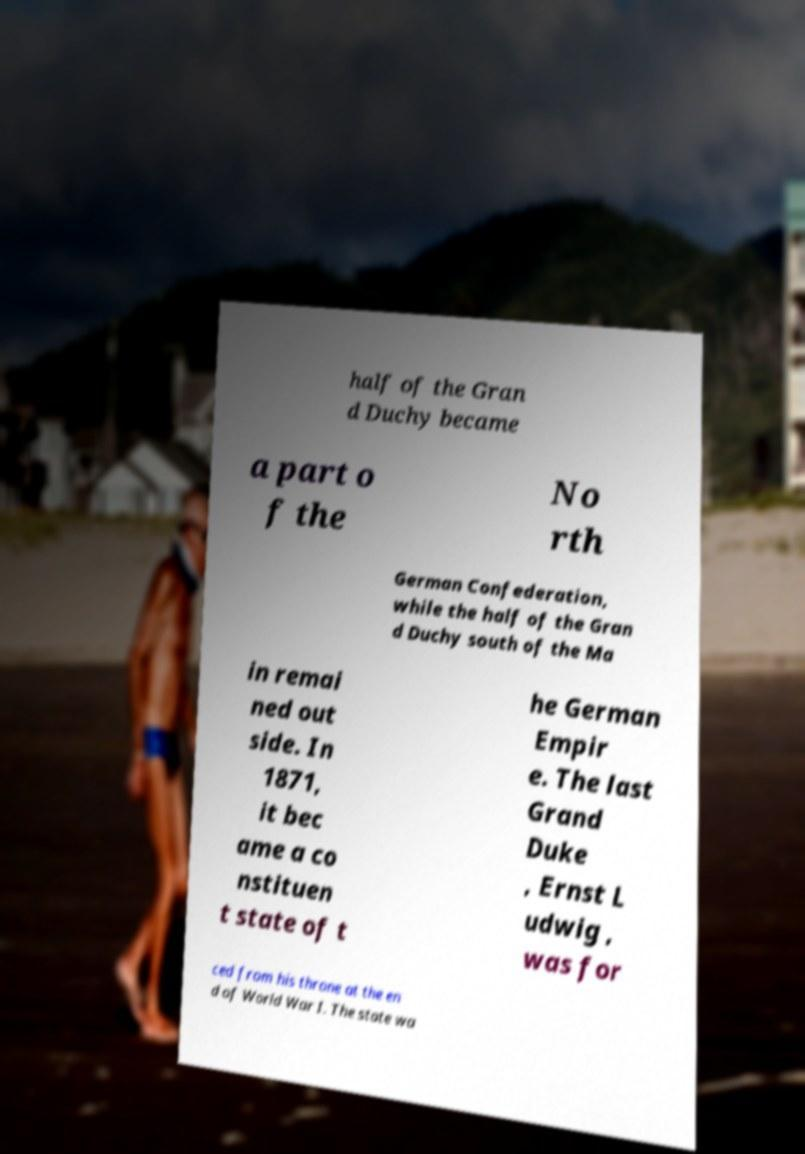Can you accurately transcribe the text from the provided image for me? half of the Gran d Duchy became a part o f the No rth German Confederation, while the half of the Gran d Duchy south of the Ma in remai ned out side. In 1871, it bec ame a co nstituen t state of t he German Empir e. The last Grand Duke , Ernst L udwig , was for ced from his throne at the en d of World War I. The state wa 